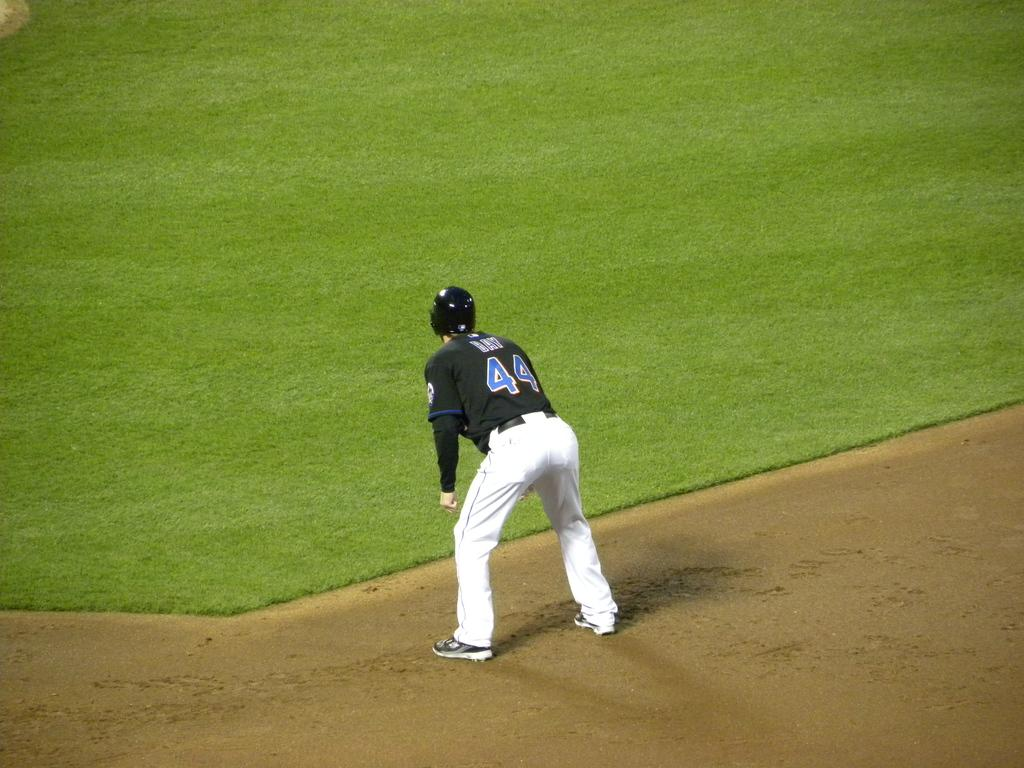<image>
Present a compact description of the photo's key features. Baseball player wearing number 44 on the grassfield. 